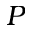Convert formula to latex. <formula><loc_0><loc_0><loc_500><loc_500>P</formula> 